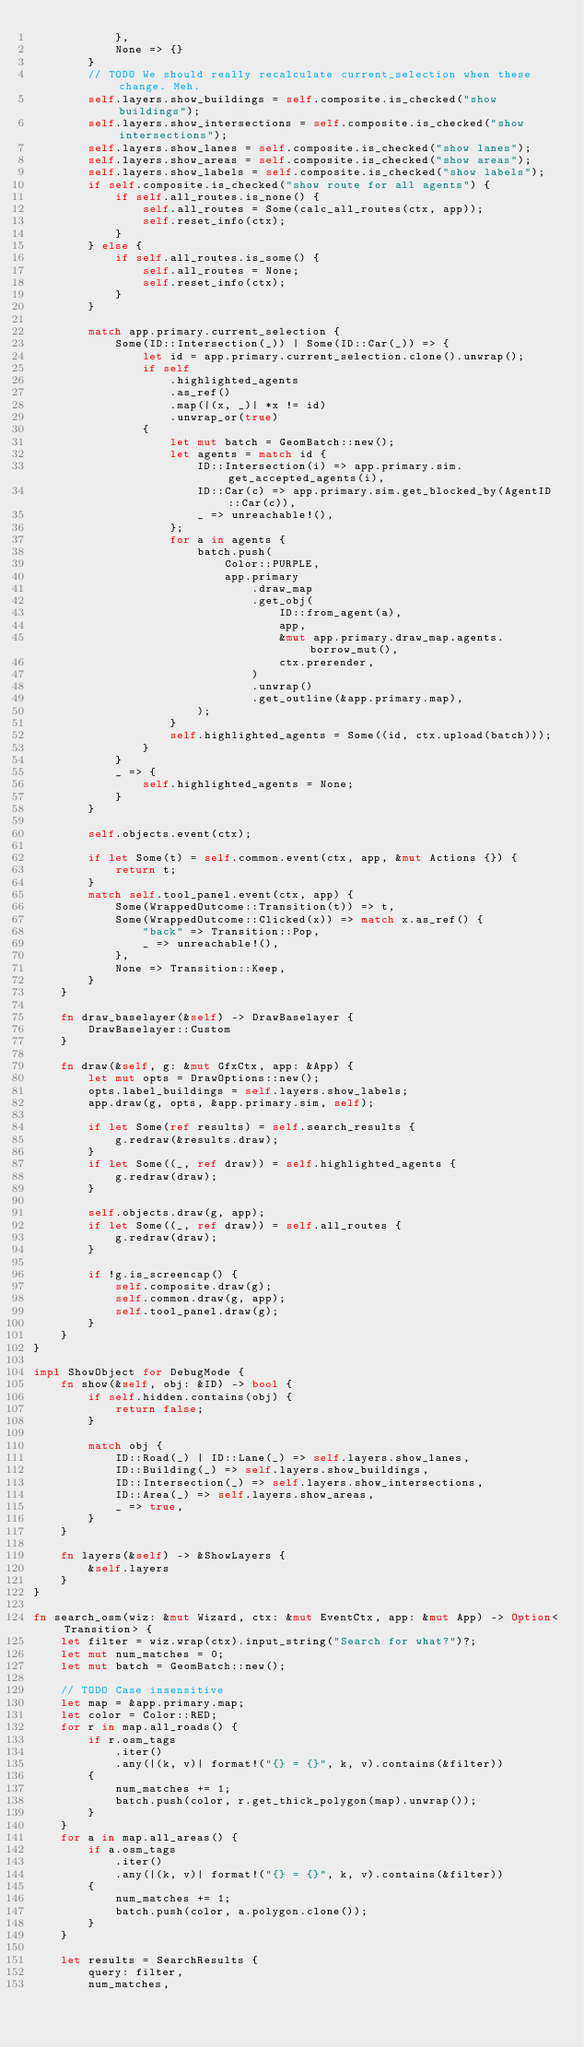Convert code to text. <code><loc_0><loc_0><loc_500><loc_500><_Rust_>            },
            None => {}
        }
        // TODO We should really recalculate current_selection when these change. Meh.
        self.layers.show_buildings = self.composite.is_checked("show buildings");
        self.layers.show_intersections = self.composite.is_checked("show intersections");
        self.layers.show_lanes = self.composite.is_checked("show lanes");
        self.layers.show_areas = self.composite.is_checked("show areas");
        self.layers.show_labels = self.composite.is_checked("show labels");
        if self.composite.is_checked("show route for all agents") {
            if self.all_routes.is_none() {
                self.all_routes = Some(calc_all_routes(ctx, app));
                self.reset_info(ctx);
            }
        } else {
            if self.all_routes.is_some() {
                self.all_routes = None;
                self.reset_info(ctx);
            }
        }

        match app.primary.current_selection {
            Some(ID::Intersection(_)) | Some(ID::Car(_)) => {
                let id = app.primary.current_selection.clone().unwrap();
                if self
                    .highlighted_agents
                    .as_ref()
                    .map(|(x, _)| *x != id)
                    .unwrap_or(true)
                {
                    let mut batch = GeomBatch::new();
                    let agents = match id {
                        ID::Intersection(i) => app.primary.sim.get_accepted_agents(i),
                        ID::Car(c) => app.primary.sim.get_blocked_by(AgentID::Car(c)),
                        _ => unreachable!(),
                    };
                    for a in agents {
                        batch.push(
                            Color::PURPLE,
                            app.primary
                                .draw_map
                                .get_obj(
                                    ID::from_agent(a),
                                    app,
                                    &mut app.primary.draw_map.agents.borrow_mut(),
                                    ctx.prerender,
                                )
                                .unwrap()
                                .get_outline(&app.primary.map),
                        );
                    }
                    self.highlighted_agents = Some((id, ctx.upload(batch)));
                }
            }
            _ => {
                self.highlighted_agents = None;
            }
        }

        self.objects.event(ctx);

        if let Some(t) = self.common.event(ctx, app, &mut Actions {}) {
            return t;
        }
        match self.tool_panel.event(ctx, app) {
            Some(WrappedOutcome::Transition(t)) => t,
            Some(WrappedOutcome::Clicked(x)) => match x.as_ref() {
                "back" => Transition::Pop,
                _ => unreachable!(),
            },
            None => Transition::Keep,
        }
    }

    fn draw_baselayer(&self) -> DrawBaselayer {
        DrawBaselayer::Custom
    }

    fn draw(&self, g: &mut GfxCtx, app: &App) {
        let mut opts = DrawOptions::new();
        opts.label_buildings = self.layers.show_labels;
        app.draw(g, opts, &app.primary.sim, self);

        if let Some(ref results) = self.search_results {
            g.redraw(&results.draw);
        }
        if let Some((_, ref draw)) = self.highlighted_agents {
            g.redraw(draw);
        }

        self.objects.draw(g, app);
        if let Some((_, ref draw)) = self.all_routes {
            g.redraw(draw);
        }

        if !g.is_screencap() {
            self.composite.draw(g);
            self.common.draw(g, app);
            self.tool_panel.draw(g);
        }
    }
}

impl ShowObject for DebugMode {
    fn show(&self, obj: &ID) -> bool {
        if self.hidden.contains(obj) {
            return false;
        }

        match obj {
            ID::Road(_) | ID::Lane(_) => self.layers.show_lanes,
            ID::Building(_) => self.layers.show_buildings,
            ID::Intersection(_) => self.layers.show_intersections,
            ID::Area(_) => self.layers.show_areas,
            _ => true,
        }
    }

    fn layers(&self) -> &ShowLayers {
        &self.layers
    }
}

fn search_osm(wiz: &mut Wizard, ctx: &mut EventCtx, app: &mut App) -> Option<Transition> {
    let filter = wiz.wrap(ctx).input_string("Search for what?")?;
    let mut num_matches = 0;
    let mut batch = GeomBatch::new();

    // TODO Case insensitive
    let map = &app.primary.map;
    let color = Color::RED;
    for r in map.all_roads() {
        if r.osm_tags
            .iter()
            .any(|(k, v)| format!("{} = {}", k, v).contains(&filter))
        {
            num_matches += 1;
            batch.push(color, r.get_thick_polygon(map).unwrap());
        }
    }
    for a in map.all_areas() {
        if a.osm_tags
            .iter()
            .any(|(k, v)| format!("{} = {}", k, v).contains(&filter))
        {
            num_matches += 1;
            batch.push(color, a.polygon.clone());
        }
    }

    let results = SearchResults {
        query: filter,
        num_matches,</code> 